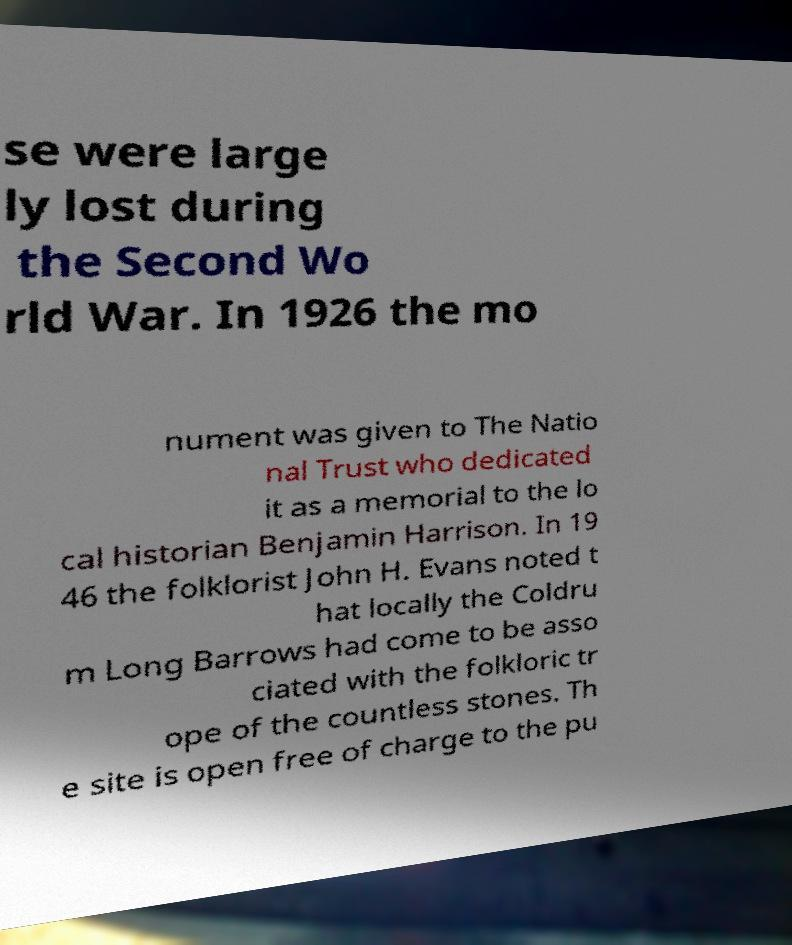I need the written content from this picture converted into text. Can you do that? se were large ly lost during the Second Wo rld War. In 1926 the mo nument was given to The Natio nal Trust who dedicated it as a memorial to the lo cal historian Benjamin Harrison. In 19 46 the folklorist John H. Evans noted t hat locally the Coldru m Long Barrows had come to be asso ciated with the folkloric tr ope of the countless stones. Th e site is open free of charge to the pu 